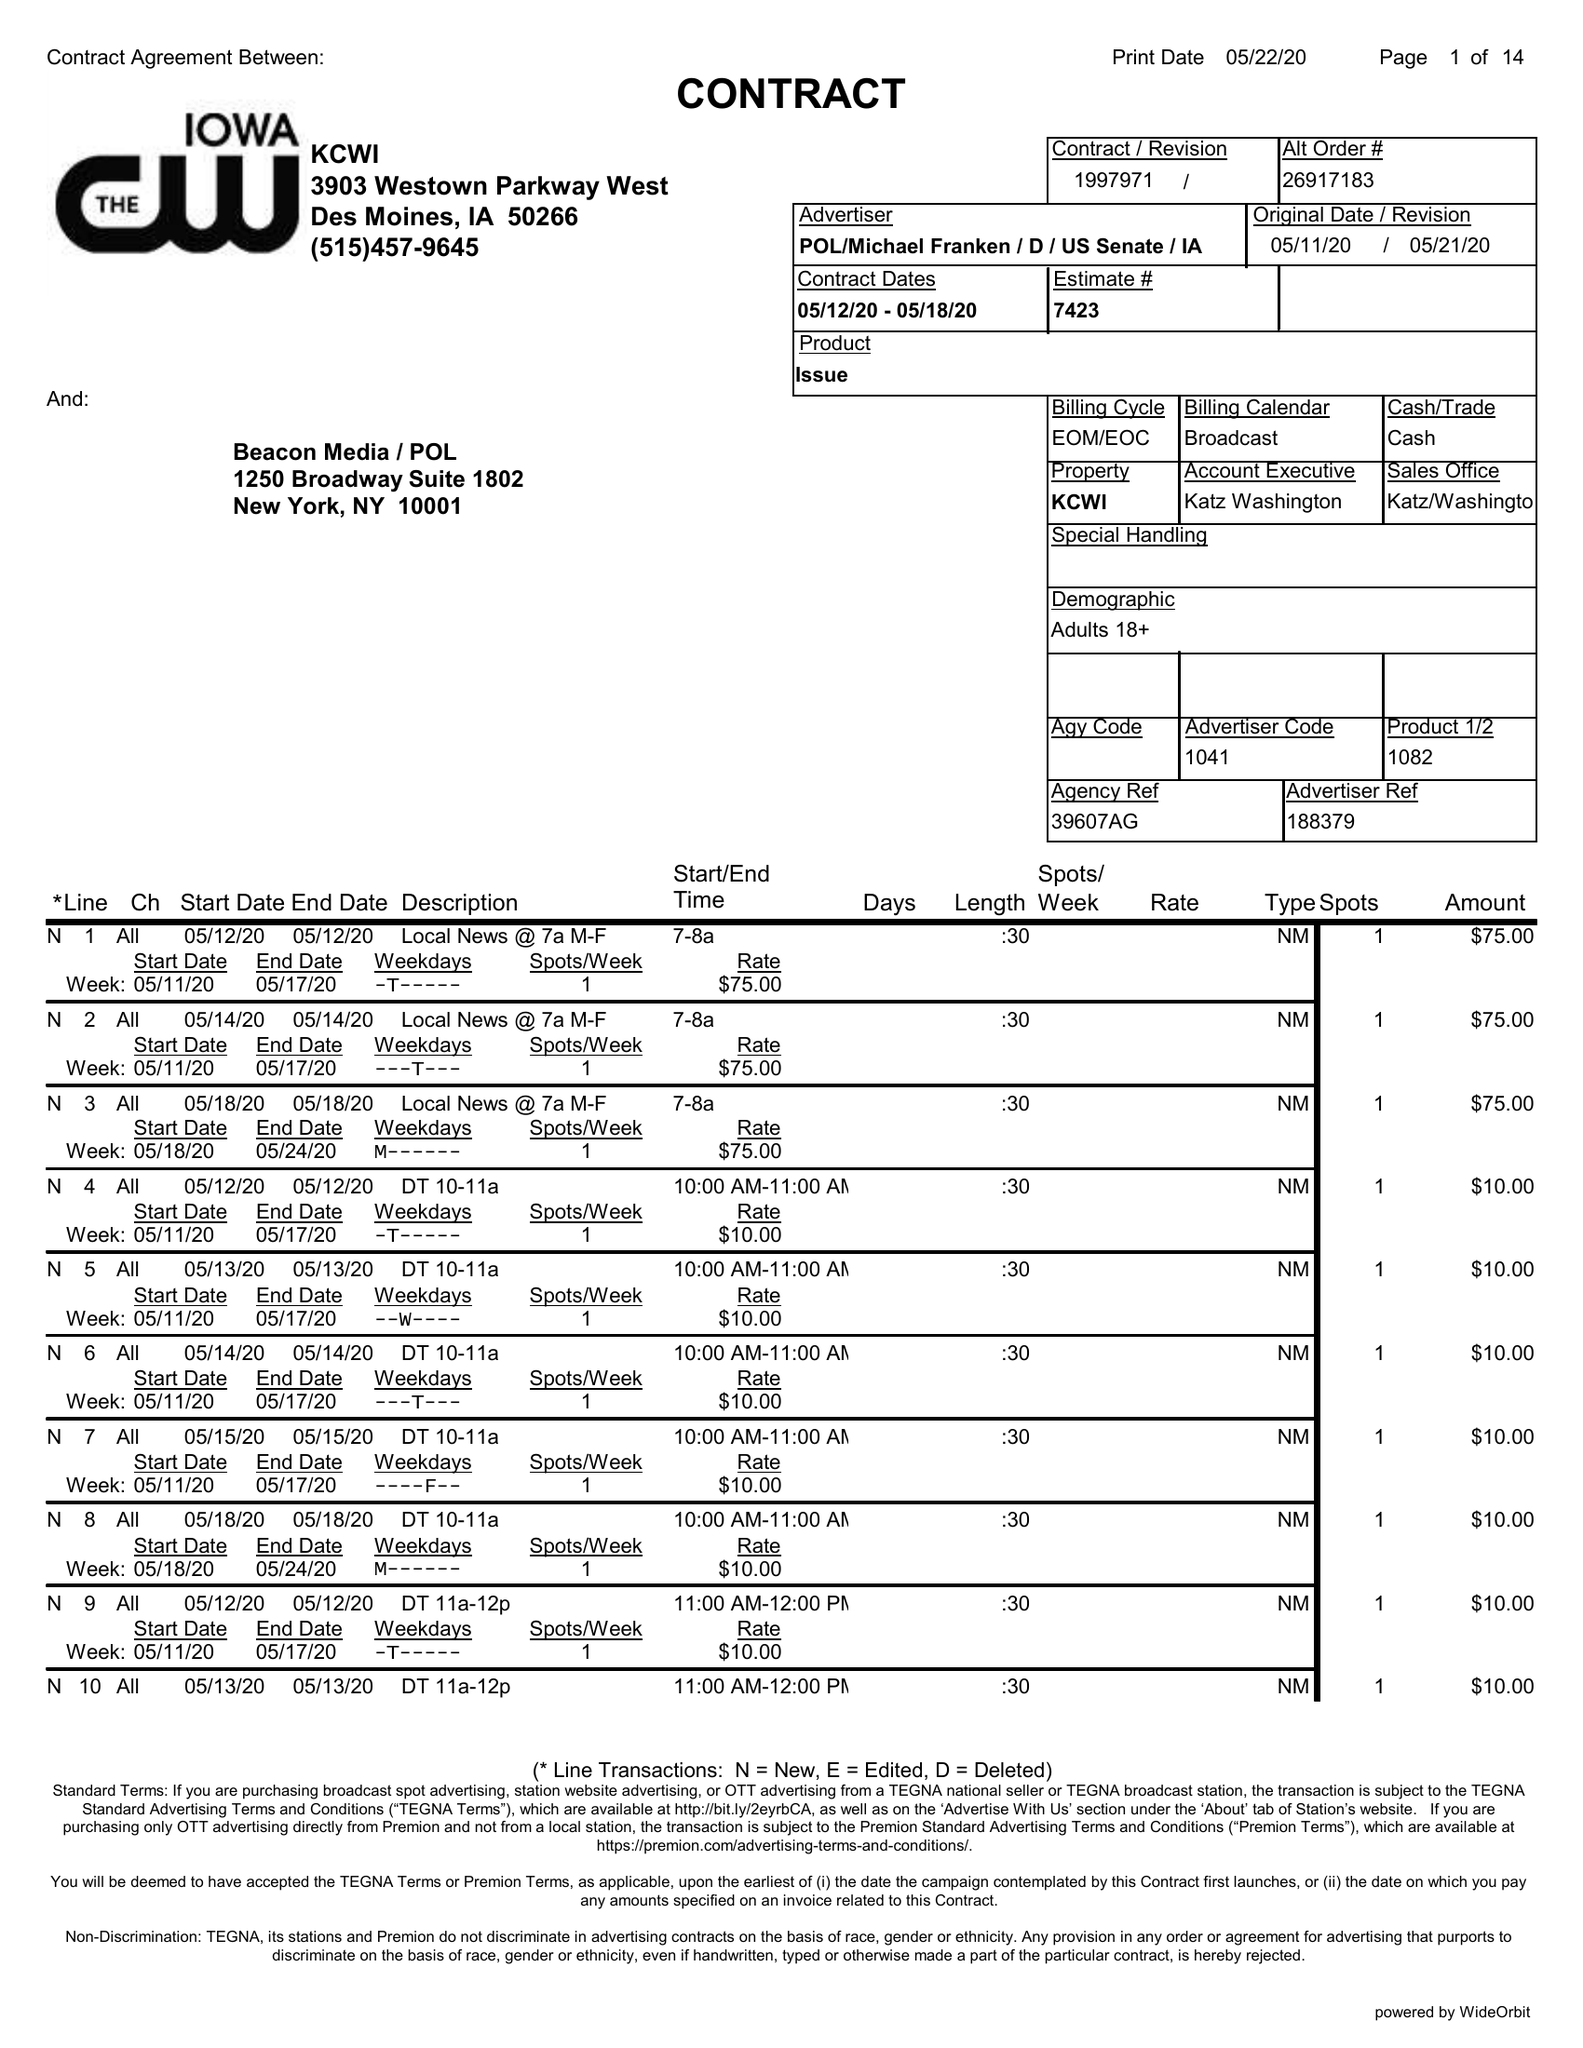What is the value for the flight_to?
Answer the question using a single word or phrase. 05/18/20 